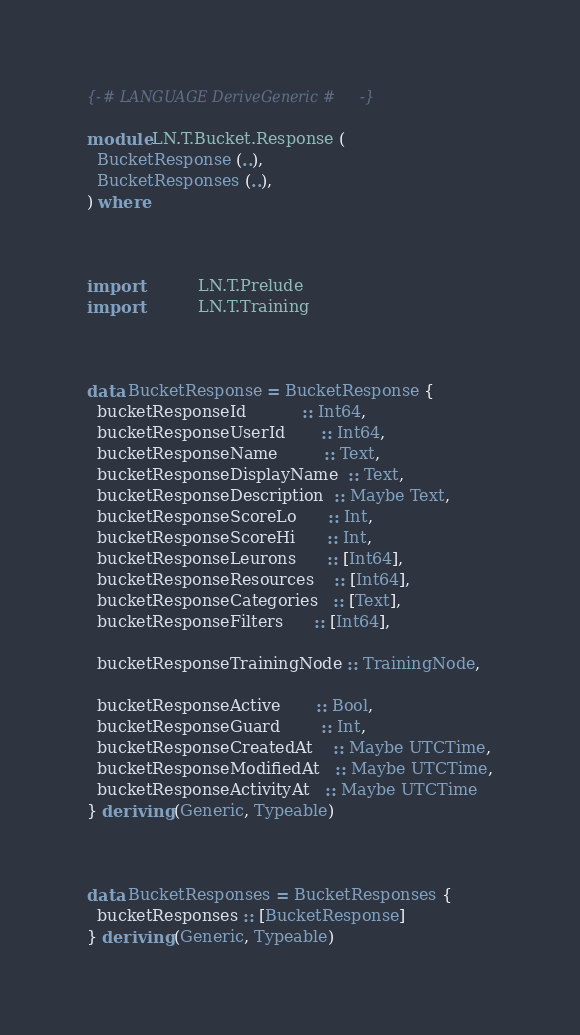Convert code to text. <code><loc_0><loc_0><loc_500><loc_500><_Haskell_>{-# LANGUAGE DeriveGeneric #-}

module LN.T.Bucket.Response (
  BucketResponse (..),
  BucketResponses (..),
) where



import           LN.T.Prelude
import           LN.T.Training



data BucketResponse = BucketResponse {
  bucketResponseId           :: Int64,
  bucketResponseUserId       :: Int64,
  bucketResponseName         :: Text,
  bucketResponseDisplayName  :: Text,
  bucketResponseDescription  :: Maybe Text,
  bucketResponseScoreLo      :: Int,
  bucketResponseScoreHi      :: Int,
  bucketResponseLeurons      :: [Int64],
  bucketResponseResources    :: [Int64],
  bucketResponseCategories   :: [Text],
  bucketResponseFilters      :: [Int64],

  bucketResponseTrainingNode :: TrainingNode,

  bucketResponseActive       :: Bool,
  bucketResponseGuard        :: Int,
  bucketResponseCreatedAt    :: Maybe UTCTime,
  bucketResponseModifiedAt   :: Maybe UTCTime,
  bucketResponseActivityAt   :: Maybe UTCTime
} deriving (Generic, Typeable)



data BucketResponses = BucketResponses {
  bucketResponses :: [BucketResponse]
} deriving (Generic, Typeable)
</code> 